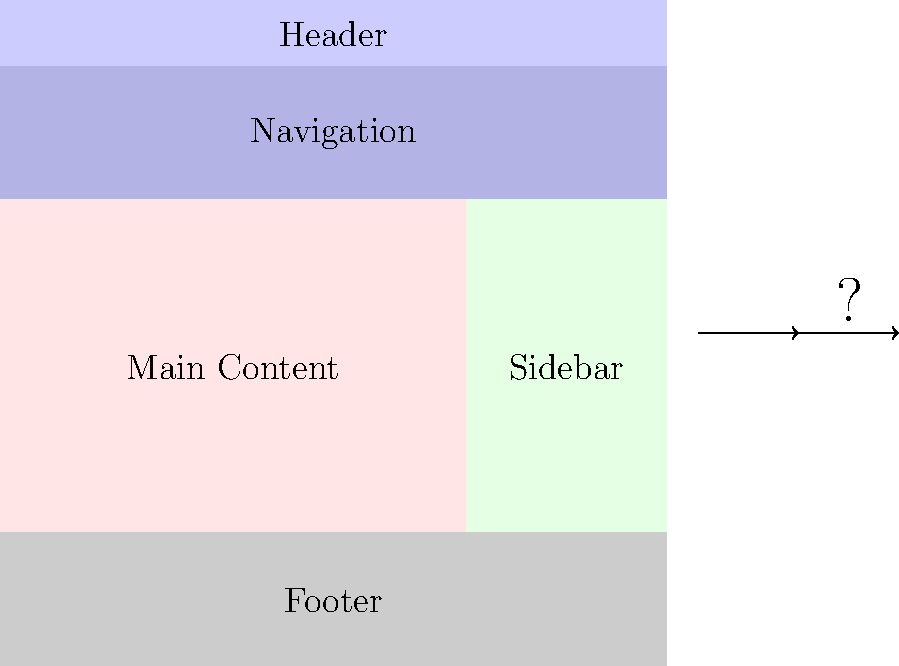As a game developer creating an anime-inspired video game website, which arrangement of elements would be most effective for user experience and visual appeal? Consider the typical layout of gaming websites and the importance of showcasing your game's unique features. To determine the optimal arrangement of website elements for an anime-inspired video game website, consider the following steps:

1. Header: Place at the top (current position) to display the game's logo and title prominently.

2. Navigation: Keep below the header (current position) for easy access to different sections of the website.

3. Main Content: 
   a) Move to the center, occupying most of the page width.
   b) This area should showcase game screenshots, trailers, and key features.

4. Sidebar:
   a) Move to the right side of the main content.
   b) Use for secondary information like release date, system requirements, or social media links.

5. Footer: Keep at the bottom (current position) for copyright information and additional links.

This arrangement follows web design best practices and caters to the gaming audience by:
- Prioritizing visual content in the center
- Providing easy navigation
- Maintaining a clean, organized layout that aligns with anime aesthetics

The optimal layout would be:

Header (top)
Navigation (below header)
Main Content (center, wide) | Sidebar (right, narrow)
Footer (bottom)

This layout ensures that the game's key visuals and information are immediately visible, improving user experience and visual appeal for the target audience.
Answer: Header-Nav-Content(center)-Sidebar(right)-Footer 